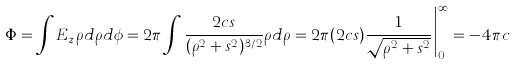<formula> <loc_0><loc_0><loc_500><loc_500>\Phi = \int E _ { z } \rho d \rho d \phi = 2 \pi \int \frac { 2 c s } { ( \rho ^ { 2 } + s ^ { 2 } ) ^ { 3 / 2 } } \rho d \rho = 2 \pi ( 2 c s ) \frac { 1 } { \sqrt { \rho ^ { 2 } + s ^ { 2 } } } \Big | ^ { \infty } _ { 0 } = - 4 \pi c</formula> 